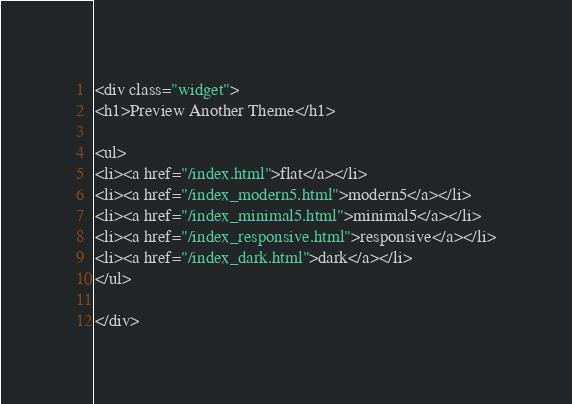<code> <loc_0><loc_0><loc_500><loc_500><_HTML_><div class="widget">
<h1>Preview Another Theme</h1>

<ul>
<li><a href="/index.html">flat</a></li>
<li><a href="/index_modern5.html">modern5</a></li>
<li><a href="/index_minimal5.html">minimal5</a></li>
<li><a href="/index_responsive.html">responsive</a></li>
<li><a href="/index_dark.html">dark</a></li>
</ul>

</div>
</code> 